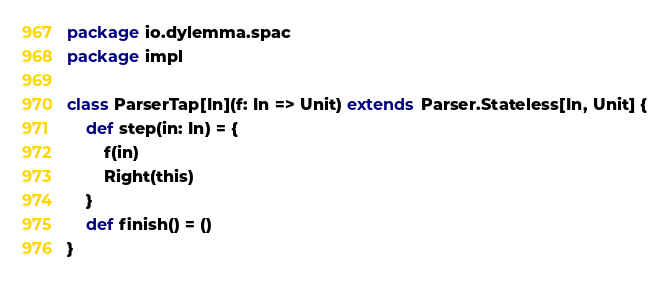<code> <loc_0><loc_0><loc_500><loc_500><_Scala_>package io.dylemma.spac
package impl

class ParserTap[In](f: In => Unit) extends Parser.Stateless[In, Unit] {
	def step(in: In) = {
		f(in)
		Right(this)
	}
	def finish() = ()
}
</code> 